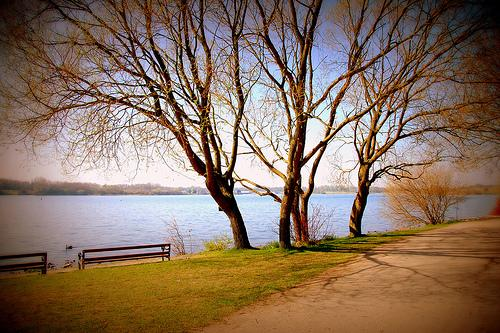Describe the area around the large body of water in the image. The large body of water is surrounded by trees, both with and without leaves, a dirt road, green grassy areas, benches, and rolling hills in the distance, creating a picturesque natural landscape. How many benches can you count in the image? There are two benches on the side of the lake. What are the main objects' interactions in the picture? The main objects in the picture include trees, a bench near a river, a pathway, and grassy areas. The trees and bench are located near the river, while the pathway and grassy areas extend along the shoreline. Evaluate the quality of the image. Is it of high quality? It is not possible for me to directly evaluate the quality of the image based on the provided information about objects and their positions. How would you interpret the mood of the image based on its elements and overall ambiance? The mood of the image is calm and peaceful, as it presents a serene natural landscape with a large body of water, trees, and green grass, under a blue sky with clouds, evoking a sense of tranquility and harmony. Depict the scene depicted in the image, focusing on the natural elements. The image portrays a serene landscape with trees, one of which is leafless, along the shores of a large blue and clear lake, with green grass and small rolling hills in the distance, under a blue sky with clouds. 